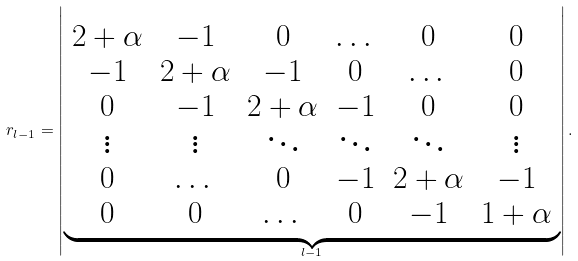Convert formula to latex. <formula><loc_0><loc_0><loc_500><loc_500>r _ { l - 1 } = \left | \underbrace { \begin{array} { c c c c c c } 2 + \alpha & - 1 & 0 & \dots & 0 & 0 \\ - 1 & 2 + \alpha & - 1 & 0 & \dots & 0 \\ 0 & - 1 & 2 + \alpha & - 1 & 0 & 0 \\ \vdots & \vdots & \ddots & \ddots & \ddots & \vdots \\ 0 & \dots & 0 & - 1 & 2 + \alpha & - 1 \\ 0 & 0 & \dots & 0 & - 1 & 1 + \alpha \\ \end{array} } _ { l - 1 } \right | .</formula> 